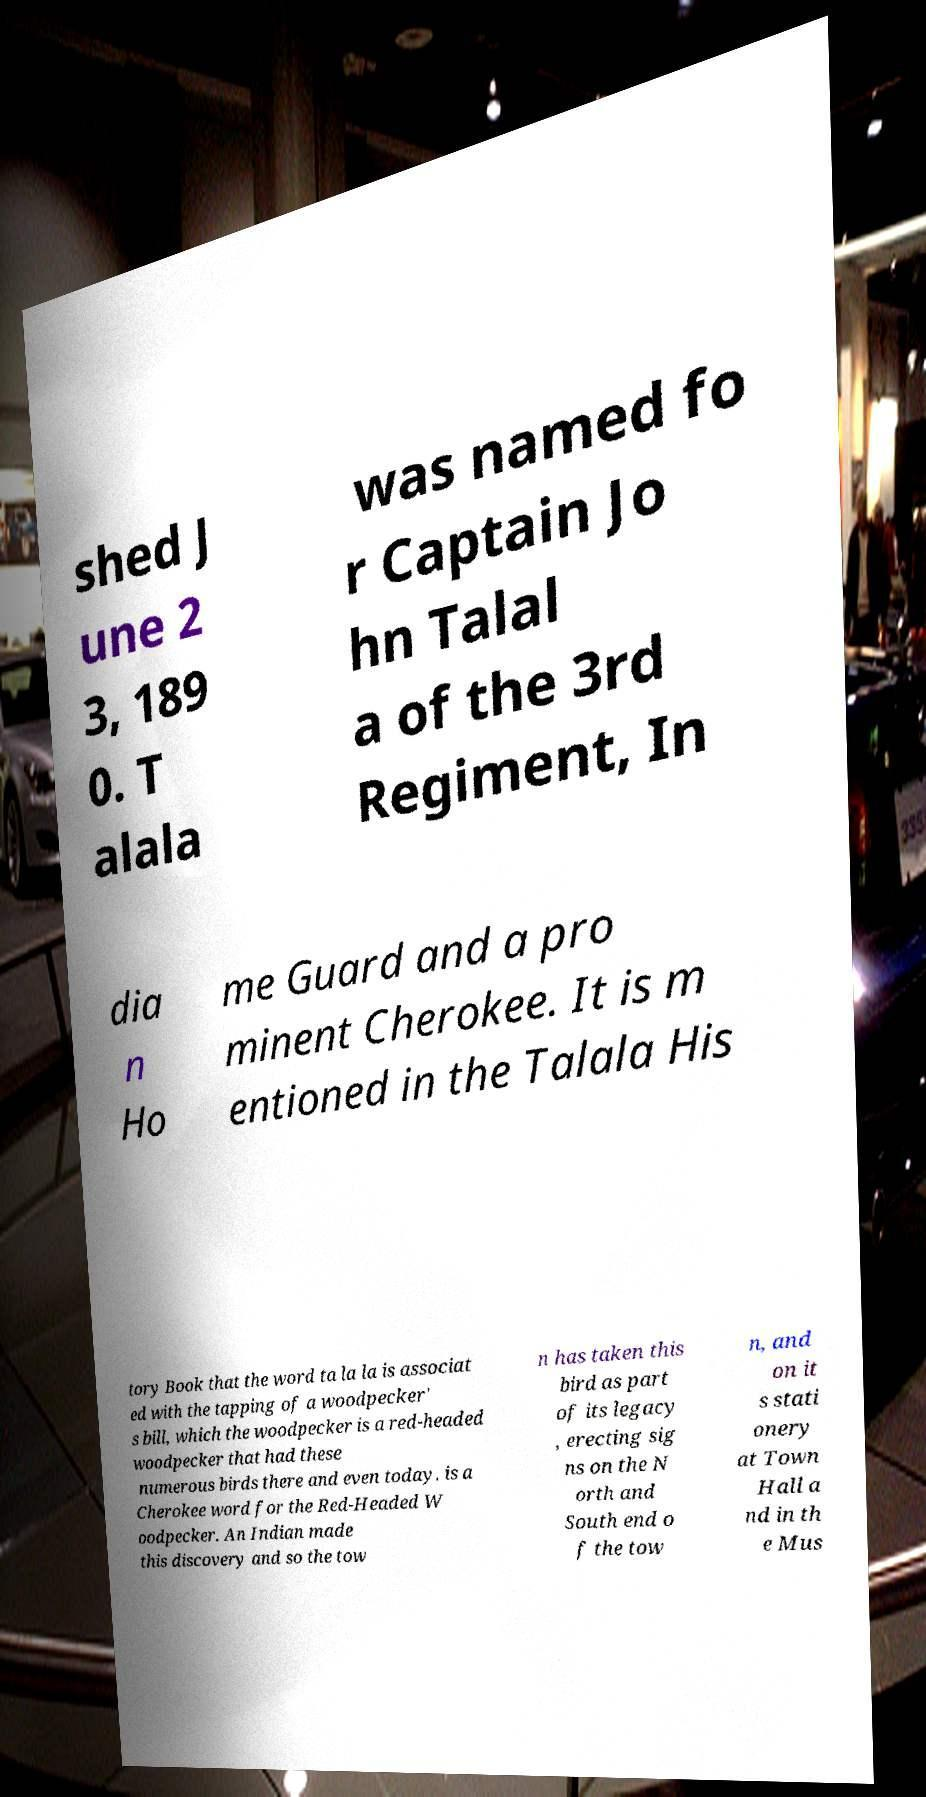What messages or text are displayed in this image? I need them in a readable, typed format. shed J une 2 3, 189 0. T alala was named fo r Captain Jo hn Talal a of the 3rd Regiment, In dia n Ho me Guard and a pro minent Cherokee. It is m entioned in the Talala His tory Book that the word ta la la is associat ed with the tapping of a woodpecker' s bill, which the woodpecker is a red-headed woodpecker that had these numerous birds there and even today. is a Cherokee word for the Red-Headed W oodpecker. An Indian made this discovery and so the tow n has taken this bird as part of its legacy , erecting sig ns on the N orth and South end o f the tow n, and on it s stati onery at Town Hall a nd in th e Mus 